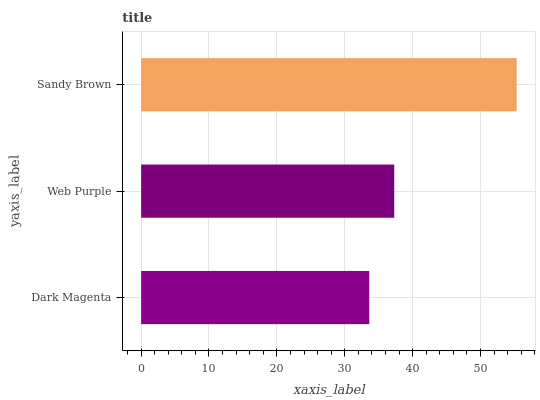Is Dark Magenta the minimum?
Answer yes or no. Yes. Is Sandy Brown the maximum?
Answer yes or no. Yes. Is Web Purple the minimum?
Answer yes or no. No. Is Web Purple the maximum?
Answer yes or no. No. Is Web Purple greater than Dark Magenta?
Answer yes or no. Yes. Is Dark Magenta less than Web Purple?
Answer yes or no. Yes. Is Dark Magenta greater than Web Purple?
Answer yes or no. No. Is Web Purple less than Dark Magenta?
Answer yes or no. No. Is Web Purple the high median?
Answer yes or no. Yes. Is Web Purple the low median?
Answer yes or no. Yes. Is Dark Magenta the high median?
Answer yes or no. No. Is Dark Magenta the low median?
Answer yes or no. No. 